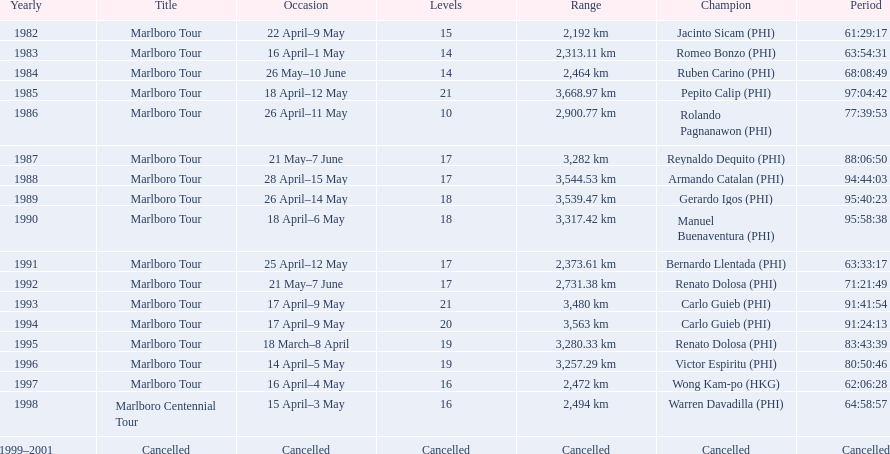What race did warren davadilla compete in in 1998? Marlboro Centennial Tour. How long did it take davadilla to complete the marlboro centennial tour? 64:58:57. 